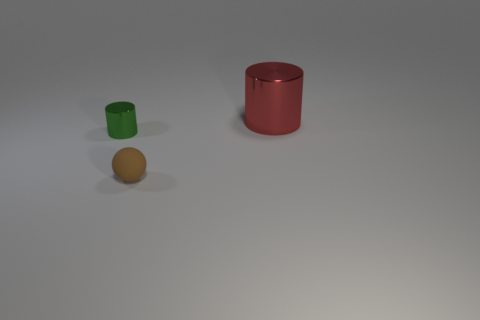How big is the red cylinder?
Provide a short and direct response. Large. Do the green metallic thing and the red metallic cylinder have the same size?
Your answer should be very brief. No. What is the size of the thing that is both behind the small brown ball and right of the small cylinder?
Your answer should be very brief. Large. Is the size of the rubber ball the same as the shiny cylinder that is on the right side of the small brown thing?
Keep it short and to the point. No. There is a metal thing behind the metal thing left of the metal thing right of the matte sphere; how big is it?
Your response must be concise. Large. There is a large cylinder that is the same material as the small cylinder; what is its color?
Your answer should be very brief. Red. Are there any cylinders of the same size as the green thing?
Provide a short and direct response. No. There is a green metallic object that is the same size as the ball; what shape is it?
Provide a succinct answer. Cylinder. Are there any other objects that have the same shape as the green shiny object?
Offer a very short reply. Yes. Is the big red object made of the same material as the cylinder that is in front of the large object?
Make the answer very short. Yes. 